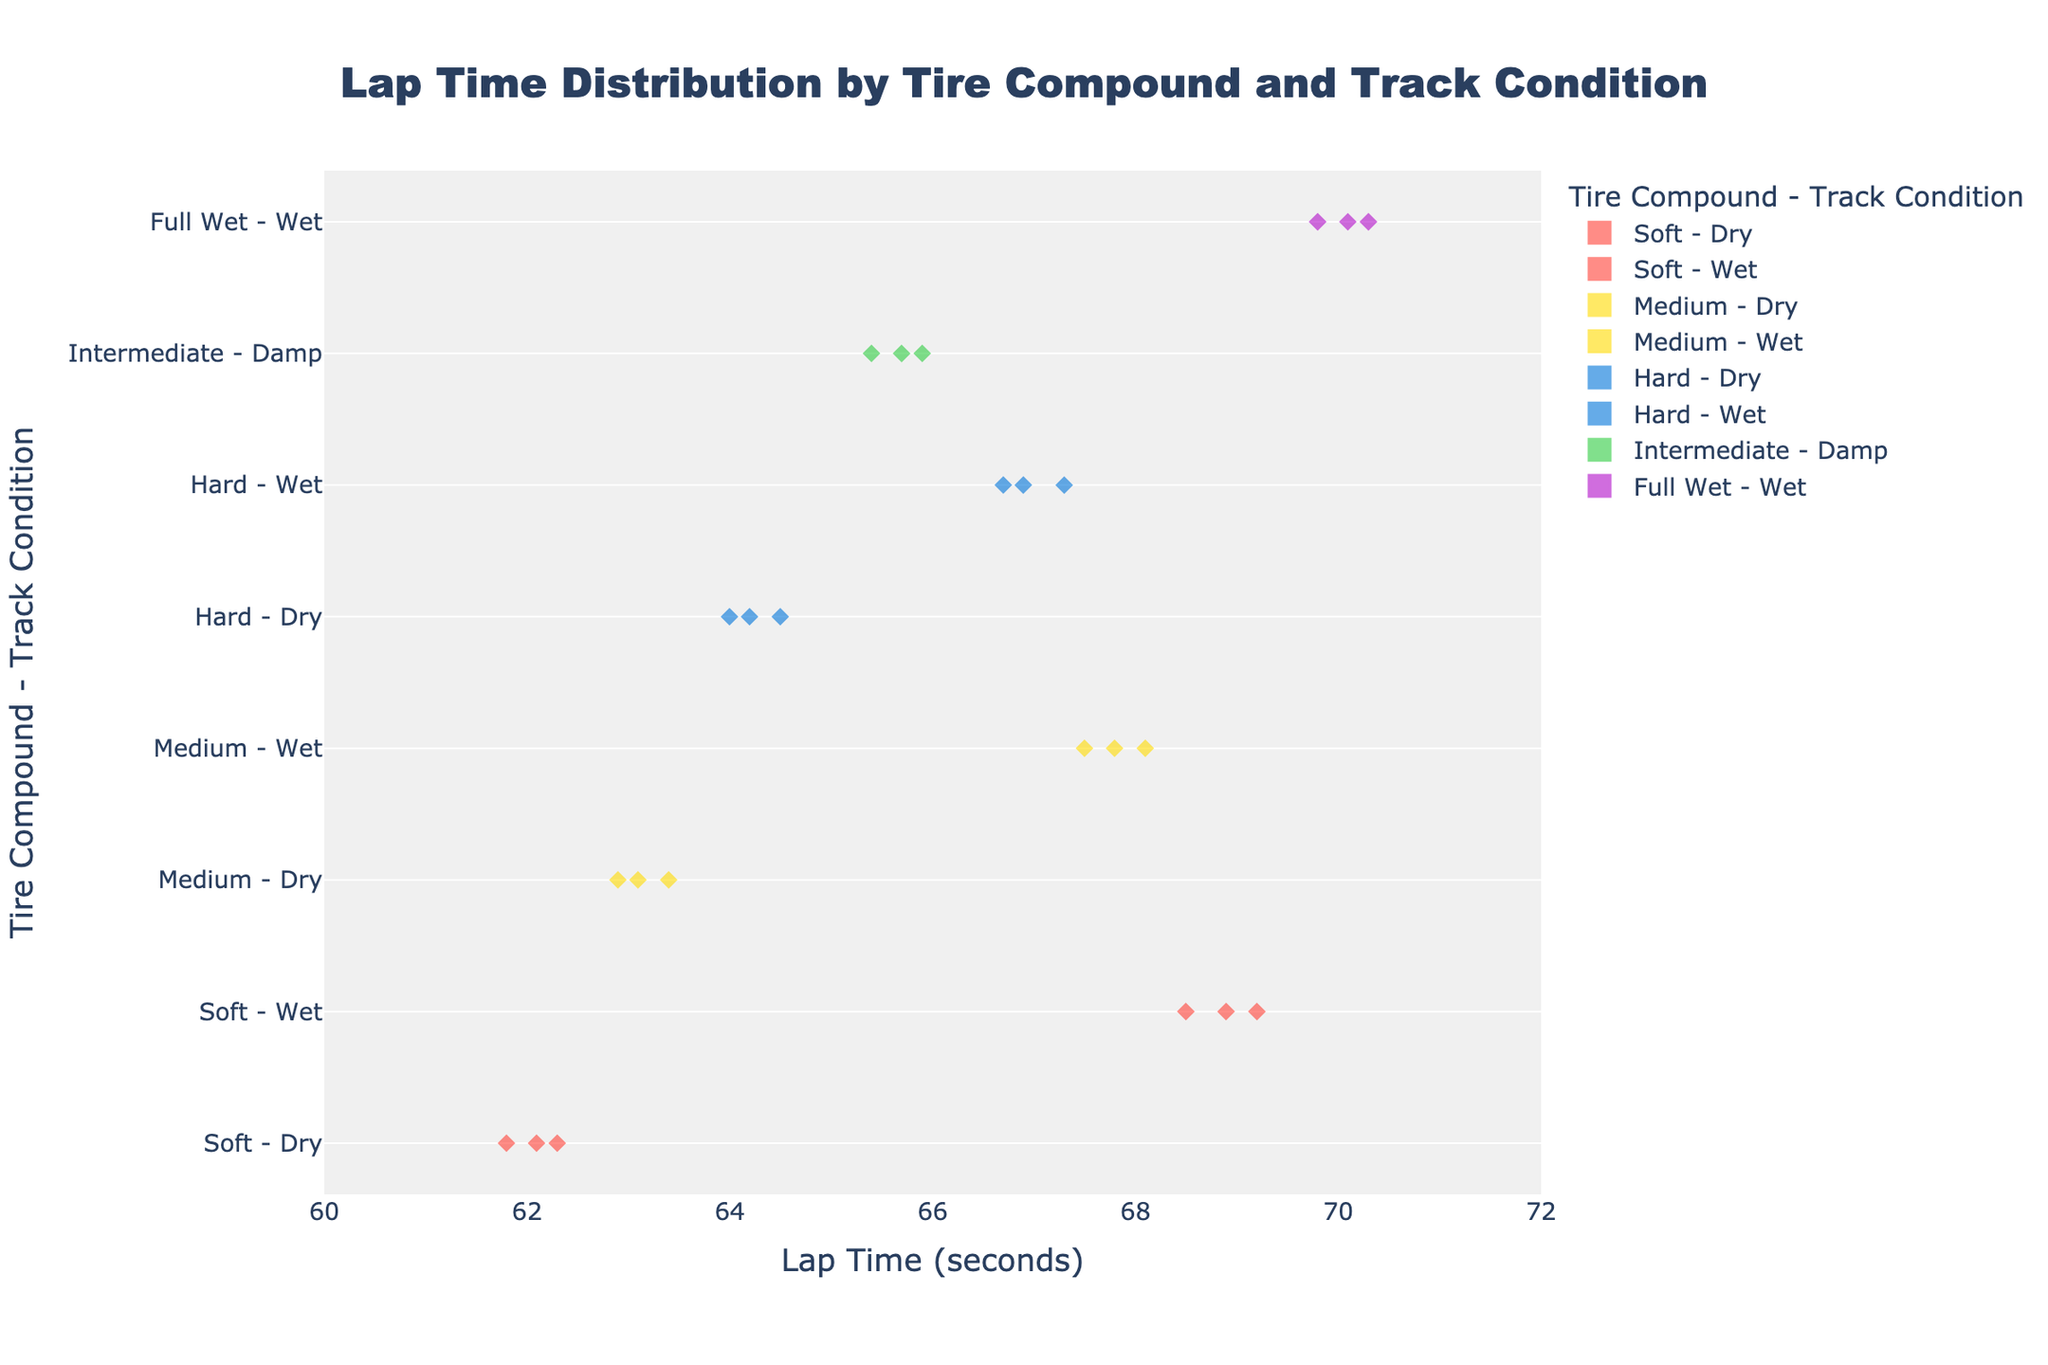What is the title of the plot? The title of the plot is provided at the top center of the figure.
Answer: Lap Time Distribution by Tire Compound and Track Condition What is the range of the x-axis (Lap Time)? The range of the x-axis can be seen from the minimum to the maximum value set on the axis.
Answer: 60 to 72 seconds Which tire compound has the highest average lap time in dry conditions? To find this, we look at the meanline (horizontal line within each density area) for each tire compound under dry conditions and compare their positions on the x-axis.
Answer: Hard How many tire compounds are evaluated in this plot? We can count the unique tire compounds listed on the y-axis of the plot in combination with any track condition.
Answer: 5 What is the lap time range for the 'Soft - Wet' condition? By observing the 'Soft - Wet' density area, we can see the range from the minimum to the maximum lap times.
Answer: 68.5 to 69.2 seconds Is the lap time more variable in 'Hard - Wet' or 'Medium - Wet' conditions? Compare the spread of the lap time data points in the 'Hard - Wet' and 'Medium - Wet' density areas horizontally.
Answer: Medium - Wet Which combination shows the smallest spread in lap times? We look for the tightest (least spread out) density area horizontally across all combinations.
Answer: Soft - Dry How does the lap time for 'Full Wet - Wet' compare to 'Intermediate - Damp'? Compare the positions of the meanlines and ranges of the lap times for 'Full Wet - Wet' and 'Intermediate - Damp' conditions horizontally.
Answer: 'Full Wet - Wet' has higher lap times than 'Intermediate - Damp' Which condition shows the most consistent lap times for the 'Soft' tire compound? Consistency can be identified by the narrowest spread in lap times for 'Soft' under each track condition.
Answer: Soft - Dry What is the median lap time for 'Medium - Dry' condition? Locate the meanline within the density area for 'Medium - Dry', which corresponds to the median lap time.
Answer: 63.1 